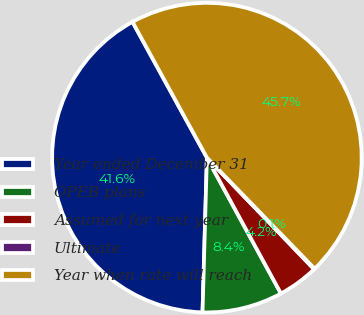Convert chart to OTSL. <chart><loc_0><loc_0><loc_500><loc_500><pie_chart><fcel>Year ended December 31<fcel>OPEB plans<fcel>Assumed for next year<fcel>Ultimate<fcel>Year when rate will reach<nl><fcel>41.57%<fcel>8.39%<fcel>4.24%<fcel>0.08%<fcel>45.72%<nl></chart> 